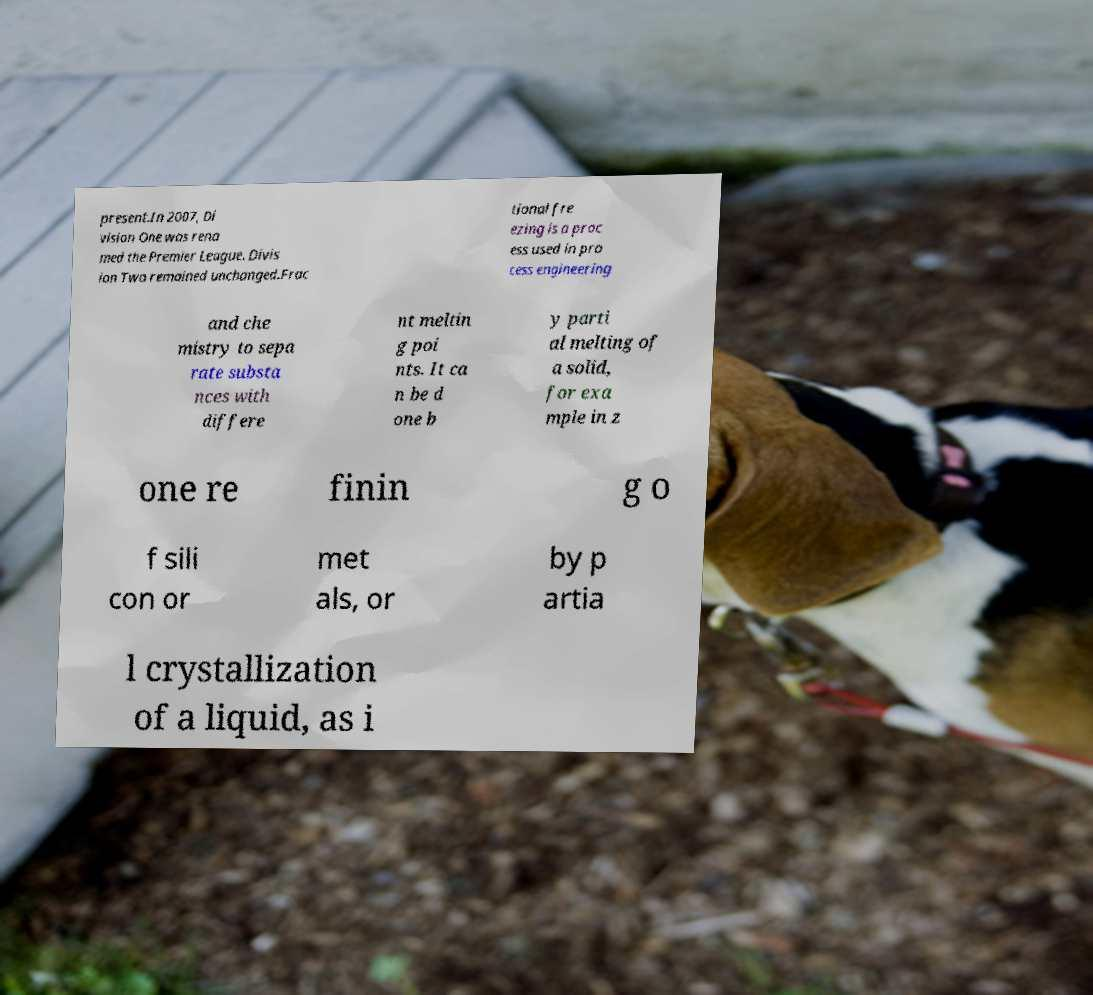Please identify and transcribe the text found in this image. present.In 2007, Di vision One was rena med the Premier League. Divis ion Two remained unchanged.Frac tional fre ezing is a proc ess used in pro cess engineering and che mistry to sepa rate substa nces with differe nt meltin g poi nts. It ca n be d one b y parti al melting of a solid, for exa mple in z one re finin g o f sili con or met als, or by p artia l crystallization of a liquid, as i 